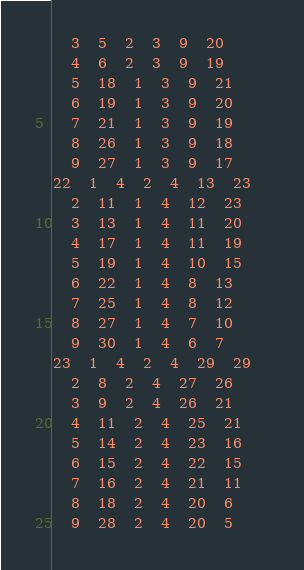Convert code to text. <code><loc_0><loc_0><loc_500><loc_500><_ObjectiveC_>	3	5	2	3	9	20	
	4	6	2	3	9	19	
	5	18	1	3	9	21	
	6	19	1	3	9	20	
	7	21	1	3	9	19	
	8	26	1	3	9	18	
	9	27	1	3	9	17	
22	1	4	2	4	13	23	
	2	11	1	4	12	23	
	3	13	1	4	11	20	
	4	17	1	4	11	19	
	5	19	1	4	10	15	
	6	22	1	4	8	13	
	7	25	1	4	8	12	
	8	27	1	4	7	10	
	9	30	1	4	6	7	
23	1	4	2	4	29	29	
	2	8	2	4	27	26	
	3	9	2	4	26	21	
	4	11	2	4	25	21	
	5	14	2	4	23	16	
	6	15	2	4	22	15	
	7	16	2	4	21	11	
	8	18	2	4	20	6	
	9	28	2	4	20	5	</code> 